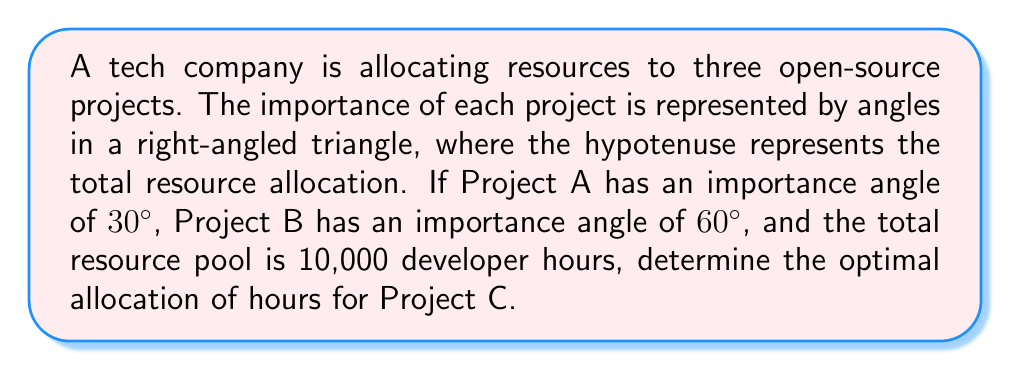Show me your answer to this math problem. Let's approach this step-by-step using trigonometric ratios:

1) First, we need to recognize that the three projects form a right-angled triangle, where:
   - Project A corresponds to the angle of 30°
   - Project B corresponds to the angle of 60°
   - Project C corresponds to the right angle (90°)

2) In a right-angled triangle, the sides are proportional to the sines of their opposite angles. We can use this principle to set up our equations.

3) Let's denote the resources for each project as follows:
   - $a$ for Project A
   - $b$ for Project B
   - $c$ for Project C

4) We know that the total resources (hypotenuse) is 10,000 hours. We can set up the following proportions:

   $$\frac{a}{10000} = \sin(30°)$$
   $$\frac{b}{10000} = \sin(60°)$$
   $$\frac{c}{10000} = \sin(90°)$$

5) We're interested in finding $c$. We know that $\sin(90°) = 1$, so:

   $$\frac{c}{10000} = 1$$
   $$c = 10000$$

6) Therefore, the optimal allocation for Project C is 10,000 hours.

7) As a check, we can calculate $a$ and $b$:
   
   $a = 10000 \times \sin(30°) = 10000 \times 0.5 = 5000$ hours
   $b = 10000 \times \sin(60°) = 10000 \times \frac{\sqrt{3}}{2} \approx 8660$ hours

   Note that $a^2 + b^2 = c^2$, confirming our calculation.
Answer: 10,000 hours 